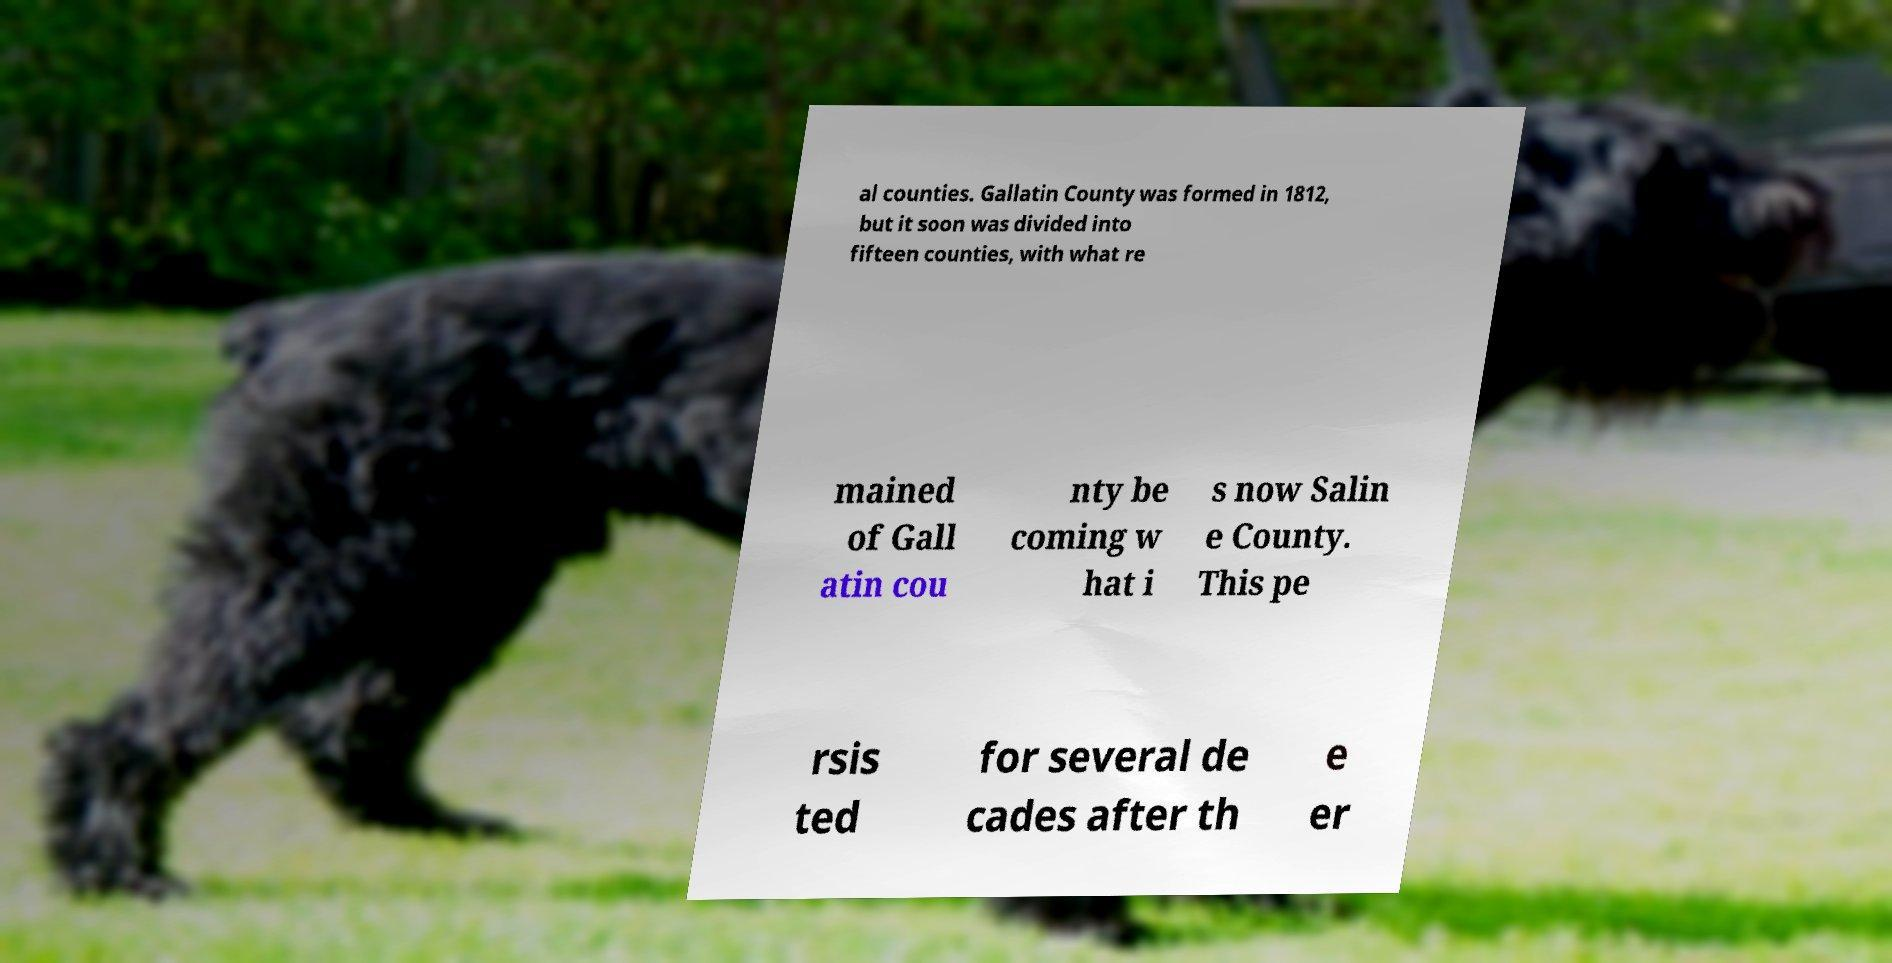Can you accurately transcribe the text from the provided image for me? al counties. Gallatin County was formed in 1812, but it soon was divided into fifteen counties, with what re mained of Gall atin cou nty be coming w hat i s now Salin e County. This pe rsis ted for several de cades after th e er 